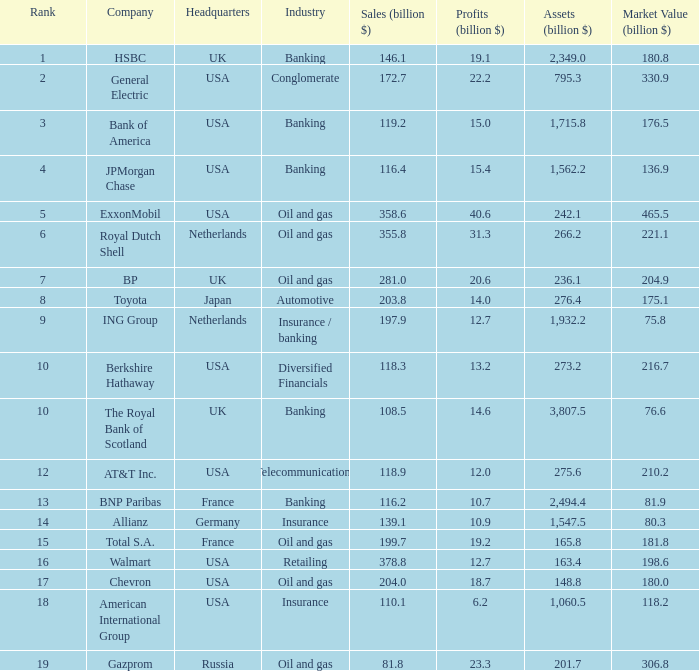8 billion in assets? 3.0. 